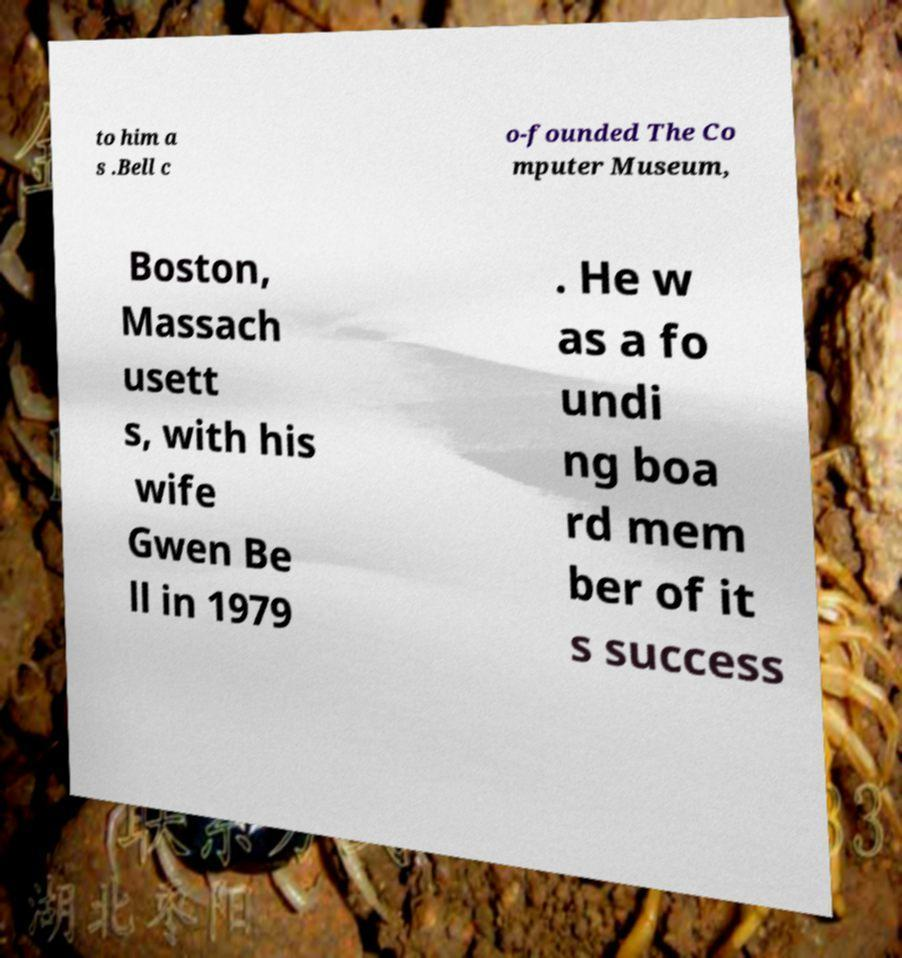I need the written content from this picture converted into text. Can you do that? to him a s .Bell c o-founded The Co mputer Museum, Boston, Massach usett s, with his wife Gwen Be ll in 1979 . He w as a fo undi ng boa rd mem ber of it s success 